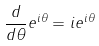<formula> <loc_0><loc_0><loc_500><loc_500>\frac { d } { d \theta } e ^ { i \theta } = i e ^ { i \theta }</formula> 